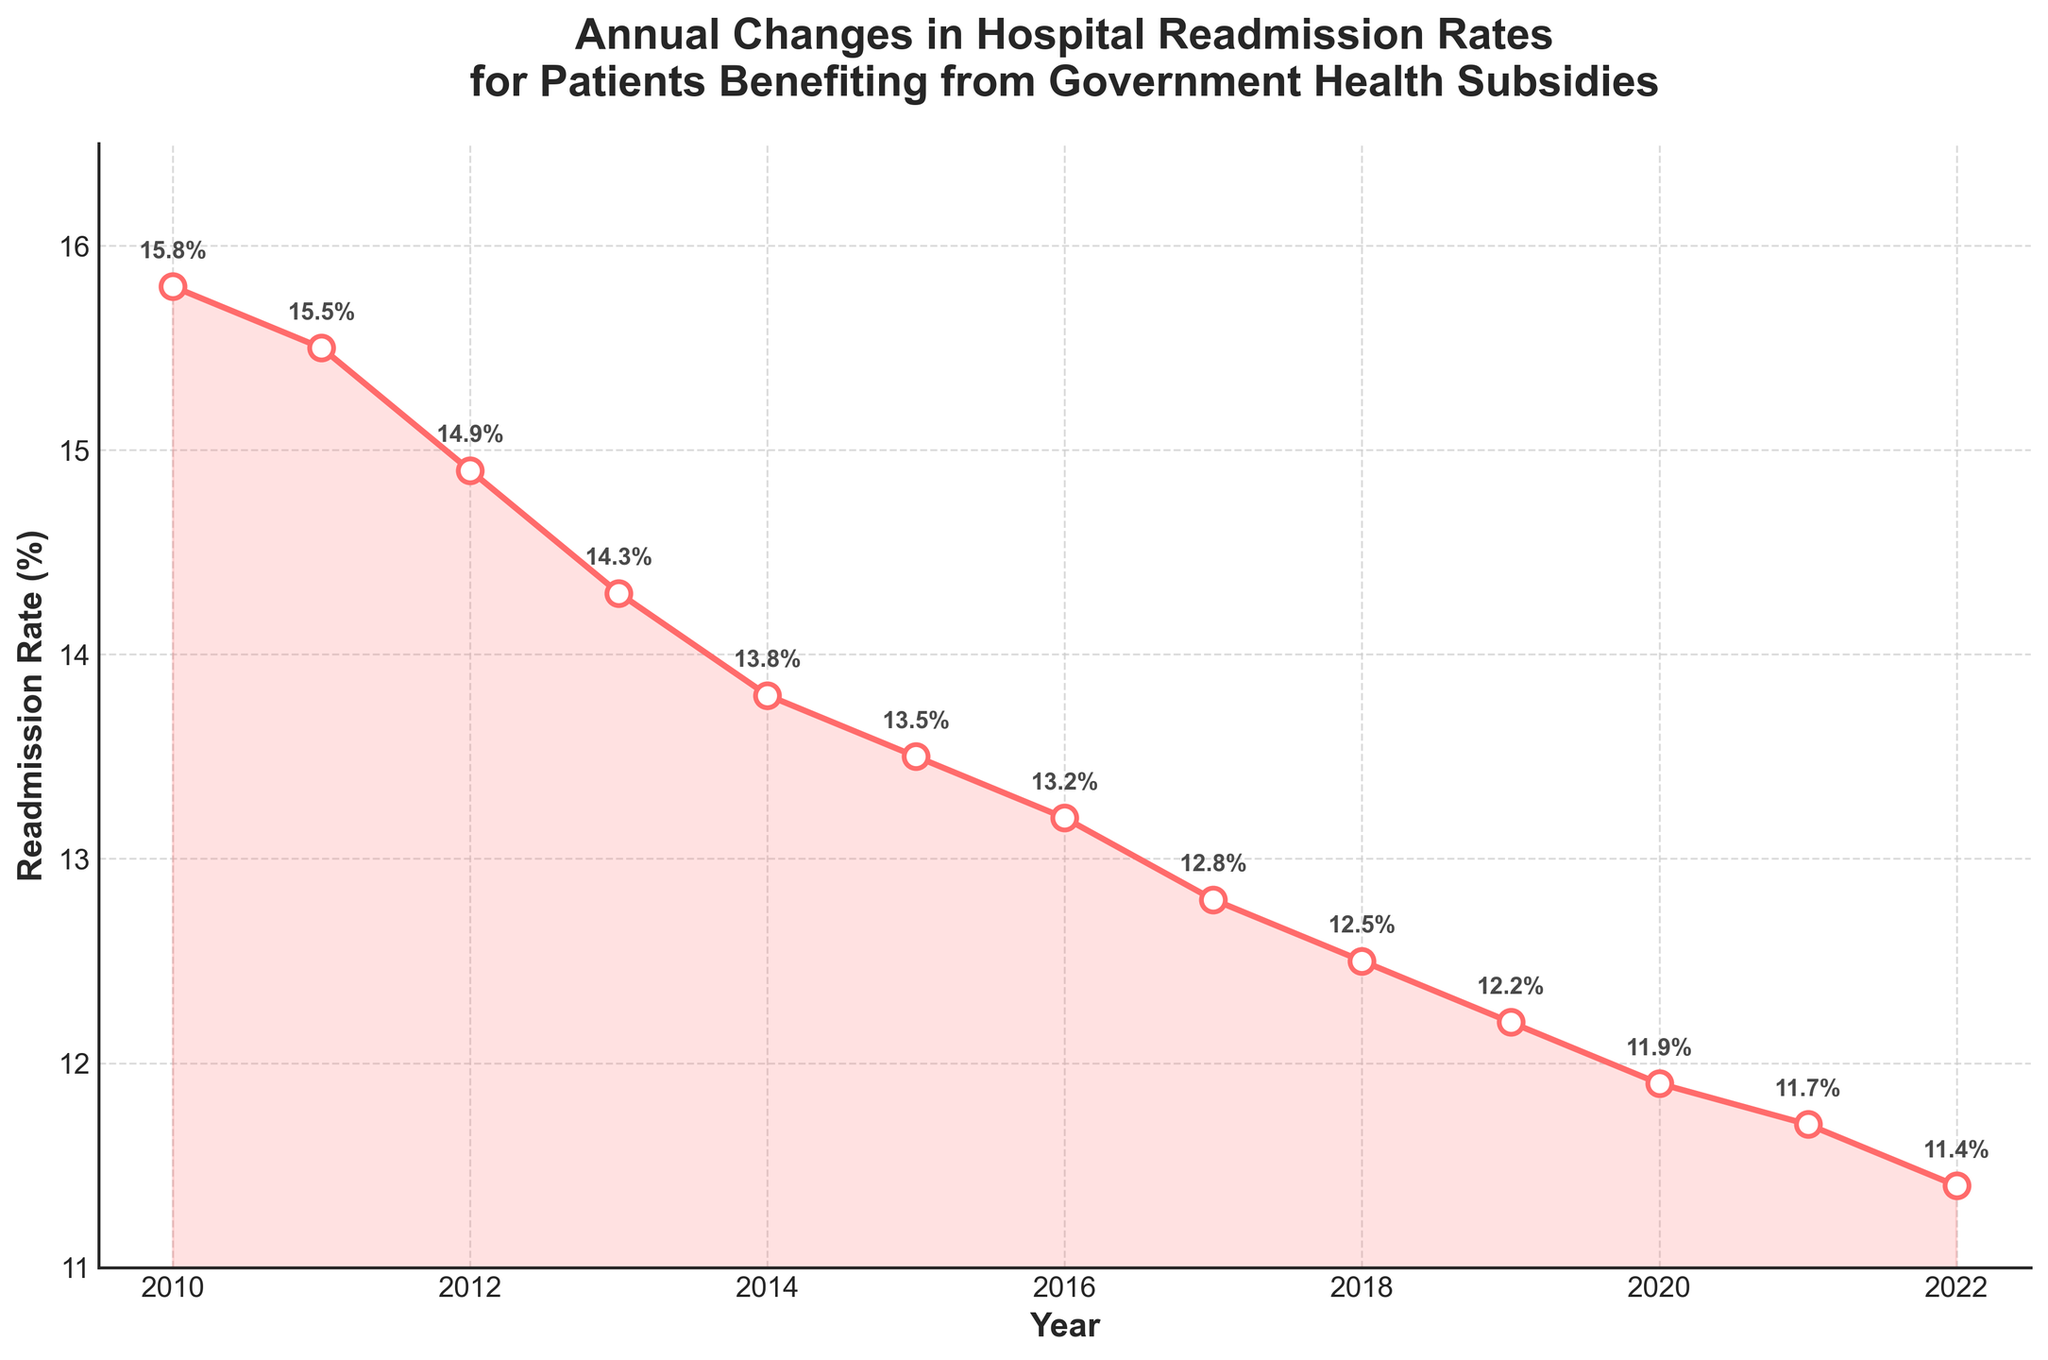What is the title of the figure? The title of the figure is located at the top and provides a summary of what the figure represents.
Answer: Annual Changes in Hospital Readmission Rates for Patients Benefiting from Government Health Subsidies How many data points are plotted on the graph? Each data point corresponds to a year from 2010 to 2022, which can be counted directly from the x-axis labels or the markers.
Answer: 13 What was the readmission rate in the year 2015? By looking at the point plotted for the year 2015 on the x-axis and its corresponding value on the y-axis, we can see the annotated value for the readmission rate.
Answer: 13.5% What is the trend of the readmission rates from 2010 to 2022? The readmission rates from 2010 to 2022 show a decreasing trend, indicated by the downward slope of the line connecting the data points.
Answer: Decreasing What is the difference in readmission rates between the years 2010 and 2022? The readmission rate in 2010 is 15.8%, and in 2022 it is 11.4%. Calculating the difference gives us 15.8% - 11.4%.
Answer: 4.4% Between which consecutive years was the largest drop in readmission rate observed? To find the largest drop, calculate the difference in readmission rates for each consecutive year and identify the maximum drop. The largest difference is between 2011 (15.5%) and 2012 (14.9%), which is 0.6%.
Answer: 2011 to 2012 What is the average readmission rate for the years 2018 to 2020? Add the readmission rates for the years 2018 (12.5%), 2019 (12.2%), and 2020 (11.9%) and then divide by 3. The calculation is (12.5 + 12.2 + 11.9) / 3.
Answer: 12.2% During which year did the readmission rate first fall below 13%? Observing the annotated values on the plot, the readmission rate first falls below 13% in the year 2017 (12.8%).
Answer: 2017 How does the readmission rate in 2020 compare to 2013? Comparing the readmission rates of 2020 (11.9%) and 2013 (14.3%) by observing their respective points on the graph or their annotations, we can see that the rate in 2020 is lower than in 2013.
Answer: Lower in 2020 